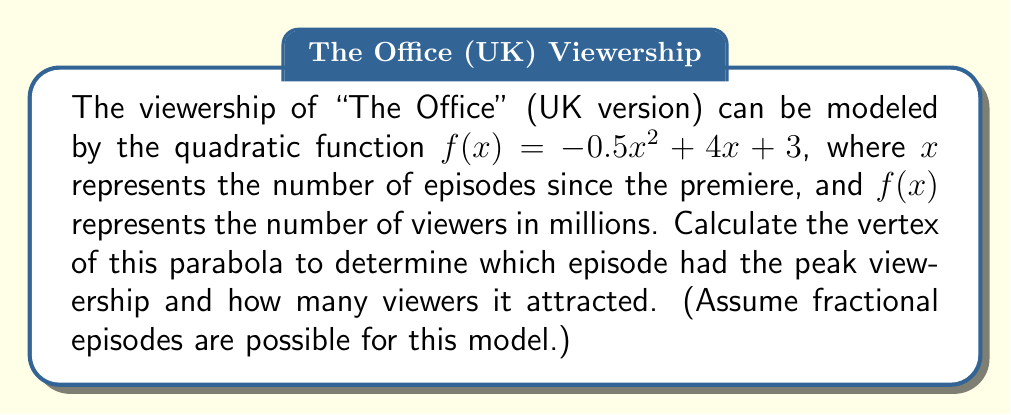Solve this math problem. To find the vertex of a parabola in the form $f(x) = ax^2 + bx + c$, we can use the formula:

$x = -\frac{b}{2a}$

1) In this case, $a = -0.5$, $b = 4$, and $c = 3$

2) Substituting these values:
   $x = -\frac{4}{2(-0.5)} = -\frac{4}{-1} = 4$

3) To find the y-coordinate of the vertex, we substitute this x-value back into the original function:

   $f(4) = -0.5(4)^2 + 4(4) + 3$
   $    = -0.5(16) + 16 + 3$
   $    = -8 + 16 + 3$
   $    = 11$

4) Therefore, the vertex is at the point (4, 11)

This means the peak viewership occurred at episode 4 (or more precisely, after the 4th episode), with 11 million viewers.
Answer: (4, 11) 